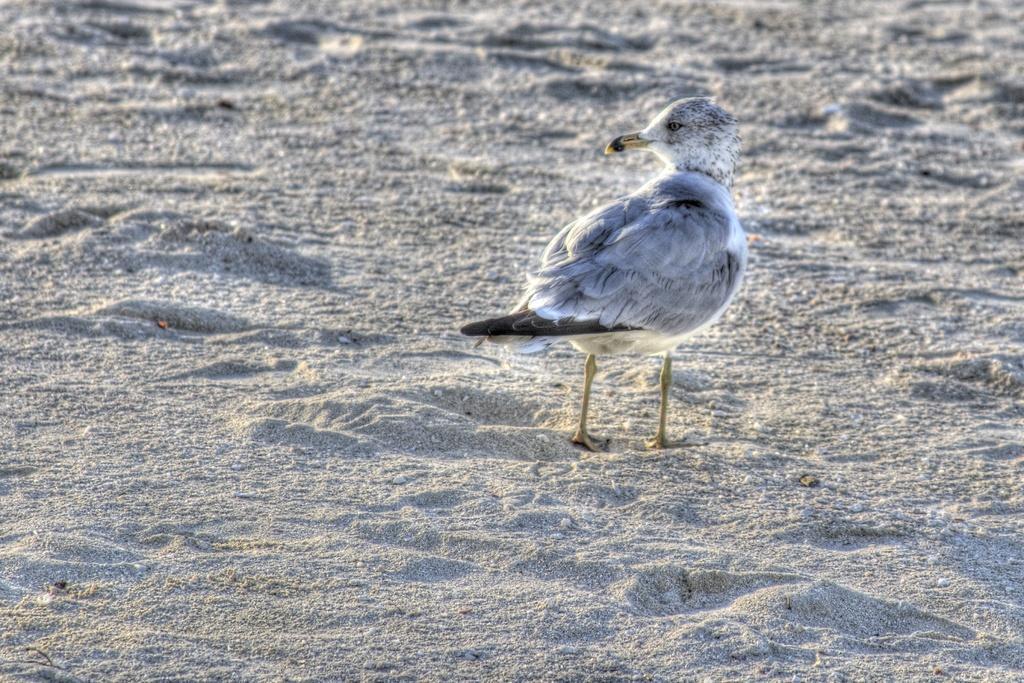Please provide a concise description of this image. In the image we can see a bird, white and black in color and here we can see sand. 